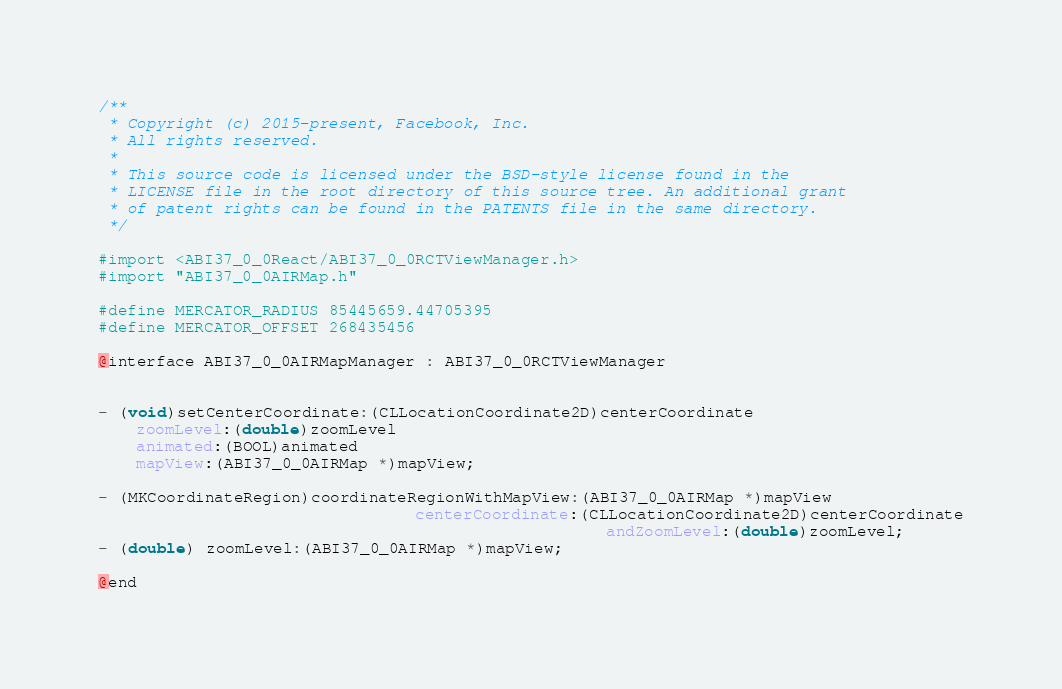Convert code to text. <code><loc_0><loc_0><loc_500><loc_500><_C_>/**
 * Copyright (c) 2015-present, Facebook, Inc.
 * All rights reserved.
 *
 * This source code is licensed under the BSD-style license found in the
 * LICENSE file in the root directory of this source tree. An additional grant
 * of patent rights can be found in the PATENTS file in the same directory.
 */

#import <ABI37_0_0React/ABI37_0_0RCTViewManager.h>
#import "ABI37_0_0AIRMap.h"

#define MERCATOR_RADIUS 85445659.44705395
#define MERCATOR_OFFSET 268435456

@interface ABI37_0_0AIRMapManager : ABI37_0_0RCTViewManager


- (void)setCenterCoordinate:(CLLocationCoordinate2D)centerCoordinate
    zoomLevel:(double)zoomLevel
    animated:(BOOL)animated
    mapView:(ABI37_0_0AIRMap *)mapView;

- (MKCoordinateRegion)coordinateRegionWithMapView:(ABI37_0_0AIRMap *)mapView
                                 centerCoordinate:(CLLocationCoordinate2D)centerCoordinate
								                     andZoomLevel:(double)zoomLevel;
- (double) zoomLevel:(ABI37_0_0AIRMap *)mapView;

@end
</code> 